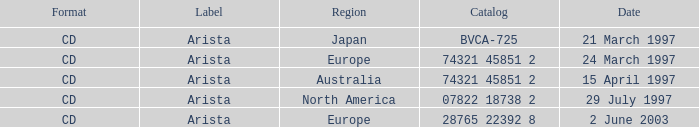Could you parse the entire table as a dict? {'header': ['Format', 'Label', 'Region', 'Catalog', 'Date'], 'rows': [['CD', 'Arista', 'Japan', 'BVCA-725', '21 March 1997'], ['CD', 'Arista', 'Europe', '74321 45851 2', '24 March 1997'], ['CD', 'Arista', 'Australia', '74321 45851 2', '15 April 1997'], ['CD', 'Arista', 'North America', '07822 18738 2', '29 July 1997'], ['CD', 'Arista', 'Europe', '28765 22392 8', '2 June 2003']]} What Format has the Region of Europe and a Catalog of 74321 45851 2? CD. 